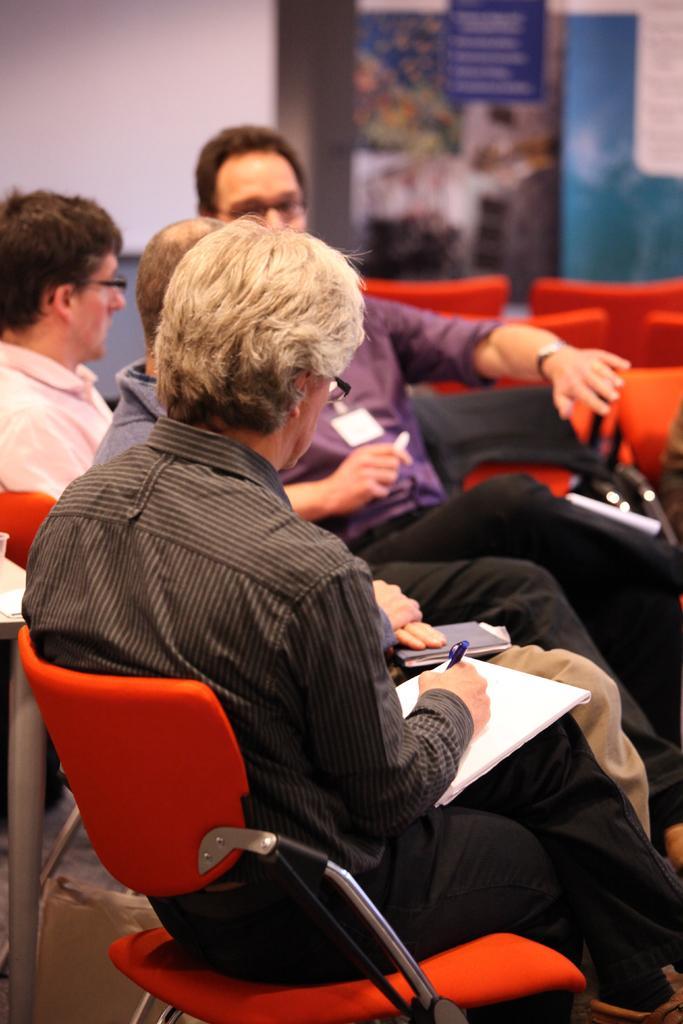Describe this image in one or two sentences. As we can see in the image there is a white color wall and few people sitting on chairs and this man is holding papers and pen. 